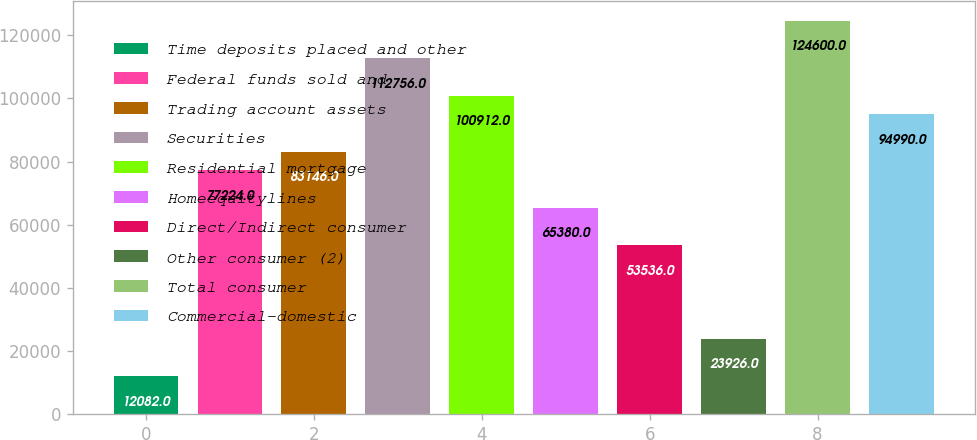<chart> <loc_0><loc_0><loc_500><loc_500><bar_chart><fcel>Time deposits placed and other<fcel>Federal funds sold and<fcel>Trading account assets<fcel>Securities<fcel>Residential mortgage<fcel>Homeequitylines<fcel>Direct/Indirect consumer<fcel>Other consumer (2)<fcel>Total consumer<fcel>Commercial-domestic<nl><fcel>12082<fcel>77224<fcel>83146<fcel>112756<fcel>100912<fcel>65380<fcel>53536<fcel>23926<fcel>124600<fcel>94990<nl></chart> 